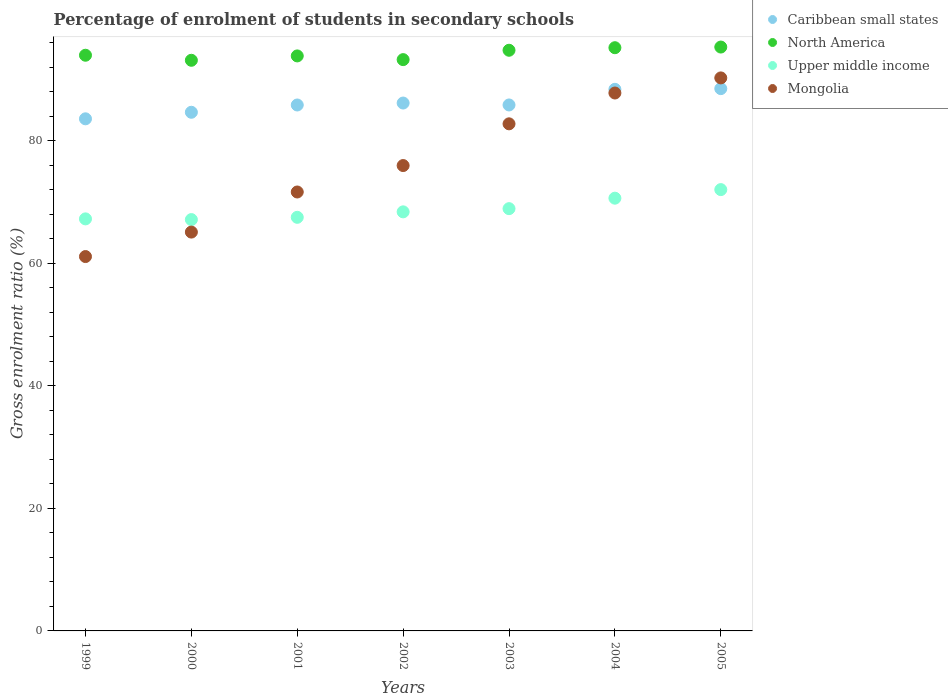What is the percentage of students enrolled in secondary schools in Mongolia in 2003?
Offer a terse response. 82.79. Across all years, what is the maximum percentage of students enrolled in secondary schools in Upper middle income?
Your response must be concise. 72.05. Across all years, what is the minimum percentage of students enrolled in secondary schools in Mongolia?
Offer a very short reply. 61.12. In which year was the percentage of students enrolled in secondary schools in Caribbean small states maximum?
Your answer should be very brief. 2005. In which year was the percentage of students enrolled in secondary schools in North America minimum?
Offer a very short reply. 2000. What is the total percentage of students enrolled in secondary schools in North America in the graph?
Provide a short and direct response. 659.68. What is the difference between the percentage of students enrolled in secondary schools in Caribbean small states in 2002 and that in 2004?
Your answer should be compact. -2.24. What is the difference between the percentage of students enrolled in secondary schools in Caribbean small states in 2003 and the percentage of students enrolled in secondary schools in Upper middle income in 1999?
Make the answer very short. 18.6. What is the average percentage of students enrolled in secondary schools in North America per year?
Make the answer very short. 94.24. In the year 2000, what is the difference between the percentage of students enrolled in secondary schools in North America and percentage of students enrolled in secondary schools in Caribbean small states?
Give a very brief answer. 8.49. What is the ratio of the percentage of students enrolled in secondary schools in North America in 2000 to that in 2005?
Make the answer very short. 0.98. Is the percentage of students enrolled in secondary schools in Upper middle income in 2000 less than that in 2004?
Provide a short and direct response. Yes. What is the difference between the highest and the second highest percentage of students enrolled in secondary schools in Upper middle income?
Your response must be concise. 1.4. What is the difference between the highest and the lowest percentage of students enrolled in secondary schools in North America?
Offer a terse response. 2.16. In how many years, is the percentage of students enrolled in secondary schools in North America greater than the average percentage of students enrolled in secondary schools in North America taken over all years?
Offer a very short reply. 3. Is the sum of the percentage of students enrolled in secondary schools in Caribbean small states in 1999 and 2003 greater than the maximum percentage of students enrolled in secondary schools in Upper middle income across all years?
Your response must be concise. Yes. Is it the case that in every year, the sum of the percentage of students enrolled in secondary schools in Upper middle income and percentage of students enrolled in secondary schools in Caribbean small states  is greater than the sum of percentage of students enrolled in secondary schools in North America and percentage of students enrolled in secondary schools in Mongolia?
Your response must be concise. No. Is the percentage of students enrolled in secondary schools in Mongolia strictly greater than the percentage of students enrolled in secondary schools in Upper middle income over the years?
Provide a short and direct response. No. Is the percentage of students enrolled in secondary schools in Caribbean small states strictly less than the percentage of students enrolled in secondary schools in Upper middle income over the years?
Ensure brevity in your answer.  No. Does the graph contain grids?
Your response must be concise. No. Where does the legend appear in the graph?
Ensure brevity in your answer.  Top right. How are the legend labels stacked?
Ensure brevity in your answer.  Vertical. What is the title of the graph?
Your answer should be very brief. Percentage of enrolment of students in secondary schools. Does "Armenia" appear as one of the legend labels in the graph?
Provide a short and direct response. No. What is the label or title of the Y-axis?
Offer a very short reply. Gross enrolment ratio (%). What is the Gross enrolment ratio (%) in Caribbean small states in 1999?
Your answer should be very brief. 83.61. What is the Gross enrolment ratio (%) in North America in 1999?
Offer a terse response. 93.99. What is the Gross enrolment ratio (%) of Upper middle income in 1999?
Provide a succinct answer. 67.27. What is the Gross enrolment ratio (%) in Mongolia in 1999?
Offer a terse response. 61.12. What is the Gross enrolment ratio (%) in Caribbean small states in 2000?
Offer a terse response. 84.68. What is the Gross enrolment ratio (%) in North America in 2000?
Your answer should be very brief. 93.17. What is the Gross enrolment ratio (%) in Upper middle income in 2000?
Keep it short and to the point. 67.16. What is the Gross enrolment ratio (%) of Mongolia in 2000?
Ensure brevity in your answer.  65.12. What is the Gross enrolment ratio (%) of Caribbean small states in 2001?
Offer a very short reply. 85.87. What is the Gross enrolment ratio (%) in North America in 2001?
Provide a succinct answer. 93.88. What is the Gross enrolment ratio (%) in Upper middle income in 2001?
Ensure brevity in your answer.  67.53. What is the Gross enrolment ratio (%) in Mongolia in 2001?
Keep it short and to the point. 71.67. What is the Gross enrolment ratio (%) in Caribbean small states in 2002?
Your answer should be very brief. 86.19. What is the Gross enrolment ratio (%) of North America in 2002?
Make the answer very short. 93.28. What is the Gross enrolment ratio (%) of Upper middle income in 2002?
Offer a terse response. 68.42. What is the Gross enrolment ratio (%) in Mongolia in 2002?
Provide a succinct answer. 75.98. What is the Gross enrolment ratio (%) in Caribbean small states in 2003?
Your answer should be compact. 85.87. What is the Gross enrolment ratio (%) of North America in 2003?
Give a very brief answer. 94.81. What is the Gross enrolment ratio (%) of Upper middle income in 2003?
Your answer should be compact. 68.94. What is the Gross enrolment ratio (%) in Mongolia in 2003?
Your response must be concise. 82.79. What is the Gross enrolment ratio (%) of Caribbean small states in 2004?
Offer a very short reply. 88.43. What is the Gross enrolment ratio (%) of North America in 2004?
Ensure brevity in your answer.  95.22. What is the Gross enrolment ratio (%) of Upper middle income in 2004?
Provide a succinct answer. 70.65. What is the Gross enrolment ratio (%) in Mongolia in 2004?
Your response must be concise. 87.83. What is the Gross enrolment ratio (%) in Caribbean small states in 2005?
Give a very brief answer. 88.54. What is the Gross enrolment ratio (%) of North America in 2005?
Make the answer very short. 95.33. What is the Gross enrolment ratio (%) in Upper middle income in 2005?
Your response must be concise. 72.05. What is the Gross enrolment ratio (%) in Mongolia in 2005?
Provide a succinct answer. 90.29. Across all years, what is the maximum Gross enrolment ratio (%) of Caribbean small states?
Ensure brevity in your answer.  88.54. Across all years, what is the maximum Gross enrolment ratio (%) in North America?
Make the answer very short. 95.33. Across all years, what is the maximum Gross enrolment ratio (%) of Upper middle income?
Provide a short and direct response. 72.05. Across all years, what is the maximum Gross enrolment ratio (%) in Mongolia?
Give a very brief answer. 90.29. Across all years, what is the minimum Gross enrolment ratio (%) in Caribbean small states?
Offer a terse response. 83.61. Across all years, what is the minimum Gross enrolment ratio (%) in North America?
Your answer should be very brief. 93.17. Across all years, what is the minimum Gross enrolment ratio (%) of Upper middle income?
Give a very brief answer. 67.16. Across all years, what is the minimum Gross enrolment ratio (%) of Mongolia?
Your response must be concise. 61.12. What is the total Gross enrolment ratio (%) in Caribbean small states in the graph?
Offer a terse response. 603.19. What is the total Gross enrolment ratio (%) in North America in the graph?
Your answer should be very brief. 659.68. What is the total Gross enrolment ratio (%) of Upper middle income in the graph?
Ensure brevity in your answer.  482.04. What is the total Gross enrolment ratio (%) in Mongolia in the graph?
Provide a short and direct response. 534.8. What is the difference between the Gross enrolment ratio (%) in Caribbean small states in 1999 and that in 2000?
Your response must be concise. -1.07. What is the difference between the Gross enrolment ratio (%) in North America in 1999 and that in 2000?
Your answer should be compact. 0.82. What is the difference between the Gross enrolment ratio (%) of Upper middle income in 1999 and that in 2000?
Your answer should be very brief. 0.12. What is the difference between the Gross enrolment ratio (%) in Mongolia in 1999 and that in 2000?
Keep it short and to the point. -3.99. What is the difference between the Gross enrolment ratio (%) in Caribbean small states in 1999 and that in 2001?
Your response must be concise. -2.26. What is the difference between the Gross enrolment ratio (%) of North America in 1999 and that in 2001?
Offer a terse response. 0.11. What is the difference between the Gross enrolment ratio (%) in Upper middle income in 1999 and that in 2001?
Your response must be concise. -0.26. What is the difference between the Gross enrolment ratio (%) in Mongolia in 1999 and that in 2001?
Offer a very short reply. -10.54. What is the difference between the Gross enrolment ratio (%) in Caribbean small states in 1999 and that in 2002?
Offer a very short reply. -2.58. What is the difference between the Gross enrolment ratio (%) in North America in 1999 and that in 2002?
Keep it short and to the point. 0.72. What is the difference between the Gross enrolment ratio (%) of Upper middle income in 1999 and that in 2002?
Make the answer very short. -1.15. What is the difference between the Gross enrolment ratio (%) of Mongolia in 1999 and that in 2002?
Keep it short and to the point. -14.86. What is the difference between the Gross enrolment ratio (%) in Caribbean small states in 1999 and that in 2003?
Provide a succinct answer. -2.26. What is the difference between the Gross enrolment ratio (%) in North America in 1999 and that in 2003?
Your response must be concise. -0.81. What is the difference between the Gross enrolment ratio (%) in Upper middle income in 1999 and that in 2003?
Provide a succinct answer. -1.67. What is the difference between the Gross enrolment ratio (%) of Mongolia in 1999 and that in 2003?
Your answer should be compact. -21.67. What is the difference between the Gross enrolment ratio (%) in Caribbean small states in 1999 and that in 2004?
Provide a succinct answer. -4.82. What is the difference between the Gross enrolment ratio (%) in North America in 1999 and that in 2004?
Keep it short and to the point. -1.23. What is the difference between the Gross enrolment ratio (%) of Upper middle income in 1999 and that in 2004?
Provide a short and direct response. -3.38. What is the difference between the Gross enrolment ratio (%) in Mongolia in 1999 and that in 2004?
Offer a terse response. -26.7. What is the difference between the Gross enrolment ratio (%) in Caribbean small states in 1999 and that in 2005?
Offer a very short reply. -4.93. What is the difference between the Gross enrolment ratio (%) of North America in 1999 and that in 2005?
Offer a terse response. -1.34. What is the difference between the Gross enrolment ratio (%) of Upper middle income in 1999 and that in 2005?
Keep it short and to the point. -4.78. What is the difference between the Gross enrolment ratio (%) of Mongolia in 1999 and that in 2005?
Your answer should be compact. -29.17. What is the difference between the Gross enrolment ratio (%) in Caribbean small states in 2000 and that in 2001?
Provide a succinct answer. -1.19. What is the difference between the Gross enrolment ratio (%) of North America in 2000 and that in 2001?
Provide a short and direct response. -0.71. What is the difference between the Gross enrolment ratio (%) in Upper middle income in 2000 and that in 2001?
Your response must be concise. -0.37. What is the difference between the Gross enrolment ratio (%) in Mongolia in 2000 and that in 2001?
Offer a very short reply. -6.55. What is the difference between the Gross enrolment ratio (%) of Caribbean small states in 2000 and that in 2002?
Offer a terse response. -1.51. What is the difference between the Gross enrolment ratio (%) of North America in 2000 and that in 2002?
Ensure brevity in your answer.  -0.11. What is the difference between the Gross enrolment ratio (%) of Upper middle income in 2000 and that in 2002?
Offer a terse response. -1.26. What is the difference between the Gross enrolment ratio (%) in Mongolia in 2000 and that in 2002?
Keep it short and to the point. -10.86. What is the difference between the Gross enrolment ratio (%) in Caribbean small states in 2000 and that in 2003?
Keep it short and to the point. -1.19. What is the difference between the Gross enrolment ratio (%) in North America in 2000 and that in 2003?
Your response must be concise. -1.64. What is the difference between the Gross enrolment ratio (%) of Upper middle income in 2000 and that in 2003?
Offer a terse response. -1.79. What is the difference between the Gross enrolment ratio (%) in Mongolia in 2000 and that in 2003?
Give a very brief answer. -17.68. What is the difference between the Gross enrolment ratio (%) of Caribbean small states in 2000 and that in 2004?
Offer a very short reply. -3.75. What is the difference between the Gross enrolment ratio (%) of North America in 2000 and that in 2004?
Provide a short and direct response. -2.05. What is the difference between the Gross enrolment ratio (%) of Upper middle income in 2000 and that in 2004?
Your answer should be very brief. -3.5. What is the difference between the Gross enrolment ratio (%) in Mongolia in 2000 and that in 2004?
Your answer should be very brief. -22.71. What is the difference between the Gross enrolment ratio (%) of Caribbean small states in 2000 and that in 2005?
Your answer should be very brief. -3.86. What is the difference between the Gross enrolment ratio (%) of North America in 2000 and that in 2005?
Your answer should be compact. -2.16. What is the difference between the Gross enrolment ratio (%) of Upper middle income in 2000 and that in 2005?
Provide a short and direct response. -4.9. What is the difference between the Gross enrolment ratio (%) of Mongolia in 2000 and that in 2005?
Ensure brevity in your answer.  -25.17. What is the difference between the Gross enrolment ratio (%) of Caribbean small states in 2001 and that in 2002?
Provide a short and direct response. -0.32. What is the difference between the Gross enrolment ratio (%) of North America in 2001 and that in 2002?
Make the answer very short. 0.6. What is the difference between the Gross enrolment ratio (%) of Upper middle income in 2001 and that in 2002?
Provide a succinct answer. -0.89. What is the difference between the Gross enrolment ratio (%) of Mongolia in 2001 and that in 2002?
Your answer should be very brief. -4.32. What is the difference between the Gross enrolment ratio (%) of Caribbean small states in 2001 and that in 2003?
Your response must be concise. -0.01. What is the difference between the Gross enrolment ratio (%) of North America in 2001 and that in 2003?
Offer a terse response. -0.93. What is the difference between the Gross enrolment ratio (%) in Upper middle income in 2001 and that in 2003?
Provide a succinct answer. -1.41. What is the difference between the Gross enrolment ratio (%) in Mongolia in 2001 and that in 2003?
Offer a terse response. -11.13. What is the difference between the Gross enrolment ratio (%) of Caribbean small states in 2001 and that in 2004?
Offer a terse response. -2.56. What is the difference between the Gross enrolment ratio (%) of North America in 2001 and that in 2004?
Offer a very short reply. -1.34. What is the difference between the Gross enrolment ratio (%) of Upper middle income in 2001 and that in 2004?
Provide a short and direct response. -3.12. What is the difference between the Gross enrolment ratio (%) of Mongolia in 2001 and that in 2004?
Ensure brevity in your answer.  -16.16. What is the difference between the Gross enrolment ratio (%) in Caribbean small states in 2001 and that in 2005?
Your answer should be very brief. -2.67. What is the difference between the Gross enrolment ratio (%) in North America in 2001 and that in 2005?
Keep it short and to the point. -1.45. What is the difference between the Gross enrolment ratio (%) in Upper middle income in 2001 and that in 2005?
Provide a succinct answer. -4.52. What is the difference between the Gross enrolment ratio (%) of Mongolia in 2001 and that in 2005?
Your answer should be very brief. -18.63. What is the difference between the Gross enrolment ratio (%) in Caribbean small states in 2002 and that in 2003?
Make the answer very short. 0.31. What is the difference between the Gross enrolment ratio (%) of North America in 2002 and that in 2003?
Offer a terse response. -1.53. What is the difference between the Gross enrolment ratio (%) of Upper middle income in 2002 and that in 2003?
Offer a terse response. -0.52. What is the difference between the Gross enrolment ratio (%) of Mongolia in 2002 and that in 2003?
Provide a succinct answer. -6.81. What is the difference between the Gross enrolment ratio (%) in Caribbean small states in 2002 and that in 2004?
Provide a short and direct response. -2.24. What is the difference between the Gross enrolment ratio (%) in North America in 2002 and that in 2004?
Your answer should be compact. -1.95. What is the difference between the Gross enrolment ratio (%) of Upper middle income in 2002 and that in 2004?
Provide a short and direct response. -2.23. What is the difference between the Gross enrolment ratio (%) of Mongolia in 2002 and that in 2004?
Keep it short and to the point. -11.84. What is the difference between the Gross enrolment ratio (%) of Caribbean small states in 2002 and that in 2005?
Give a very brief answer. -2.35. What is the difference between the Gross enrolment ratio (%) of North America in 2002 and that in 2005?
Make the answer very short. -2.05. What is the difference between the Gross enrolment ratio (%) in Upper middle income in 2002 and that in 2005?
Provide a short and direct response. -3.63. What is the difference between the Gross enrolment ratio (%) in Mongolia in 2002 and that in 2005?
Offer a terse response. -14.31. What is the difference between the Gross enrolment ratio (%) in Caribbean small states in 2003 and that in 2004?
Offer a terse response. -2.55. What is the difference between the Gross enrolment ratio (%) in North America in 2003 and that in 2004?
Your answer should be compact. -0.42. What is the difference between the Gross enrolment ratio (%) of Upper middle income in 2003 and that in 2004?
Your answer should be compact. -1.71. What is the difference between the Gross enrolment ratio (%) of Mongolia in 2003 and that in 2004?
Provide a succinct answer. -5.03. What is the difference between the Gross enrolment ratio (%) in Caribbean small states in 2003 and that in 2005?
Your response must be concise. -2.67. What is the difference between the Gross enrolment ratio (%) in North America in 2003 and that in 2005?
Provide a short and direct response. -0.52. What is the difference between the Gross enrolment ratio (%) of Upper middle income in 2003 and that in 2005?
Provide a succinct answer. -3.11. What is the difference between the Gross enrolment ratio (%) in Mongolia in 2003 and that in 2005?
Your answer should be compact. -7.5. What is the difference between the Gross enrolment ratio (%) in Caribbean small states in 2004 and that in 2005?
Give a very brief answer. -0.11. What is the difference between the Gross enrolment ratio (%) in North America in 2004 and that in 2005?
Your answer should be very brief. -0.11. What is the difference between the Gross enrolment ratio (%) of Upper middle income in 2004 and that in 2005?
Your answer should be compact. -1.4. What is the difference between the Gross enrolment ratio (%) in Mongolia in 2004 and that in 2005?
Your answer should be very brief. -2.47. What is the difference between the Gross enrolment ratio (%) in Caribbean small states in 1999 and the Gross enrolment ratio (%) in North America in 2000?
Keep it short and to the point. -9.56. What is the difference between the Gross enrolment ratio (%) in Caribbean small states in 1999 and the Gross enrolment ratio (%) in Upper middle income in 2000?
Your response must be concise. 16.45. What is the difference between the Gross enrolment ratio (%) of Caribbean small states in 1999 and the Gross enrolment ratio (%) of Mongolia in 2000?
Your answer should be very brief. 18.49. What is the difference between the Gross enrolment ratio (%) of North America in 1999 and the Gross enrolment ratio (%) of Upper middle income in 2000?
Make the answer very short. 26.83. What is the difference between the Gross enrolment ratio (%) in North America in 1999 and the Gross enrolment ratio (%) in Mongolia in 2000?
Make the answer very short. 28.88. What is the difference between the Gross enrolment ratio (%) in Upper middle income in 1999 and the Gross enrolment ratio (%) in Mongolia in 2000?
Provide a succinct answer. 2.16. What is the difference between the Gross enrolment ratio (%) in Caribbean small states in 1999 and the Gross enrolment ratio (%) in North America in 2001?
Give a very brief answer. -10.27. What is the difference between the Gross enrolment ratio (%) in Caribbean small states in 1999 and the Gross enrolment ratio (%) in Upper middle income in 2001?
Ensure brevity in your answer.  16.08. What is the difference between the Gross enrolment ratio (%) of Caribbean small states in 1999 and the Gross enrolment ratio (%) of Mongolia in 2001?
Provide a succinct answer. 11.95. What is the difference between the Gross enrolment ratio (%) in North America in 1999 and the Gross enrolment ratio (%) in Upper middle income in 2001?
Offer a terse response. 26.46. What is the difference between the Gross enrolment ratio (%) in North America in 1999 and the Gross enrolment ratio (%) in Mongolia in 2001?
Your answer should be very brief. 22.33. What is the difference between the Gross enrolment ratio (%) in Upper middle income in 1999 and the Gross enrolment ratio (%) in Mongolia in 2001?
Offer a very short reply. -4.39. What is the difference between the Gross enrolment ratio (%) in Caribbean small states in 1999 and the Gross enrolment ratio (%) in North America in 2002?
Make the answer very short. -9.66. What is the difference between the Gross enrolment ratio (%) of Caribbean small states in 1999 and the Gross enrolment ratio (%) of Upper middle income in 2002?
Provide a short and direct response. 15.19. What is the difference between the Gross enrolment ratio (%) of Caribbean small states in 1999 and the Gross enrolment ratio (%) of Mongolia in 2002?
Offer a terse response. 7.63. What is the difference between the Gross enrolment ratio (%) in North America in 1999 and the Gross enrolment ratio (%) in Upper middle income in 2002?
Your answer should be very brief. 25.57. What is the difference between the Gross enrolment ratio (%) of North America in 1999 and the Gross enrolment ratio (%) of Mongolia in 2002?
Offer a terse response. 18.01. What is the difference between the Gross enrolment ratio (%) in Upper middle income in 1999 and the Gross enrolment ratio (%) in Mongolia in 2002?
Your answer should be very brief. -8.71. What is the difference between the Gross enrolment ratio (%) of Caribbean small states in 1999 and the Gross enrolment ratio (%) of North America in 2003?
Provide a short and direct response. -11.19. What is the difference between the Gross enrolment ratio (%) of Caribbean small states in 1999 and the Gross enrolment ratio (%) of Upper middle income in 2003?
Offer a very short reply. 14.67. What is the difference between the Gross enrolment ratio (%) of Caribbean small states in 1999 and the Gross enrolment ratio (%) of Mongolia in 2003?
Offer a terse response. 0.82. What is the difference between the Gross enrolment ratio (%) in North America in 1999 and the Gross enrolment ratio (%) in Upper middle income in 2003?
Your answer should be compact. 25.05. What is the difference between the Gross enrolment ratio (%) in North America in 1999 and the Gross enrolment ratio (%) in Mongolia in 2003?
Make the answer very short. 11.2. What is the difference between the Gross enrolment ratio (%) in Upper middle income in 1999 and the Gross enrolment ratio (%) in Mongolia in 2003?
Your answer should be very brief. -15.52. What is the difference between the Gross enrolment ratio (%) of Caribbean small states in 1999 and the Gross enrolment ratio (%) of North America in 2004?
Provide a short and direct response. -11.61. What is the difference between the Gross enrolment ratio (%) of Caribbean small states in 1999 and the Gross enrolment ratio (%) of Upper middle income in 2004?
Your answer should be very brief. 12.96. What is the difference between the Gross enrolment ratio (%) of Caribbean small states in 1999 and the Gross enrolment ratio (%) of Mongolia in 2004?
Ensure brevity in your answer.  -4.21. What is the difference between the Gross enrolment ratio (%) in North America in 1999 and the Gross enrolment ratio (%) in Upper middle income in 2004?
Offer a very short reply. 23.34. What is the difference between the Gross enrolment ratio (%) of North America in 1999 and the Gross enrolment ratio (%) of Mongolia in 2004?
Offer a very short reply. 6.17. What is the difference between the Gross enrolment ratio (%) in Upper middle income in 1999 and the Gross enrolment ratio (%) in Mongolia in 2004?
Give a very brief answer. -20.55. What is the difference between the Gross enrolment ratio (%) in Caribbean small states in 1999 and the Gross enrolment ratio (%) in North America in 2005?
Offer a terse response. -11.72. What is the difference between the Gross enrolment ratio (%) in Caribbean small states in 1999 and the Gross enrolment ratio (%) in Upper middle income in 2005?
Offer a very short reply. 11.56. What is the difference between the Gross enrolment ratio (%) in Caribbean small states in 1999 and the Gross enrolment ratio (%) in Mongolia in 2005?
Your response must be concise. -6.68. What is the difference between the Gross enrolment ratio (%) of North America in 1999 and the Gross enrolment ratio (%) of Upper middle income in 2005?
Your response must be concise. 21.94. What is the difference between the Gross enrolment ratio (%) in North America in 1999 and the Gross enrolment ratio (%) in Mongolia in 2005?
Your answer should be compact. 3.7. What is the difference between the Gross enrolment ratio (%) in Upper middle income in 1999 and the Gross enrolment ratio (%) in Mongolia in 2005?
Keep it short and to the point. -23.02. What is the difference between the Gross enrolment ratio (%) of Caribbean small states in 2000 and the Gross enrolment ratio (%) of North America in 2001?
Your answer should be very brief. -9.2. What is the difference between the Gross enrolment ratio (%) of Caribbean small states in 2000 and the Gross enrolment ratio (%) of Upper middle income in 2001?
Make the answer very short. 17.15. What is the difference between the Gross enrolment ratio (%) of Caribbean small states in 2000 and the Gross enrolment ratio (%) of Mongolia in 2001?
Offer a terse response. 13.02. What is the difference between the Gross enrolment ratio (%) of North America in 2000 and the Gross enrolment ratio (%) of Upper middle income in 2001?
Offer a terse response. 25.64. What is the difference between the Gross enrolment ratio (%) in North America in 2000 and the Gross enrolment ratio (%) in Mongolia in 2001?
Keep it short and to the point. 21.5. What is the difference between the Gross enrolment ratio (%) of Upper middle income in 2000 and the Gross enrolment ratio (%) of Mongolia in 2001?
Offer a terse response. -4.51. What is the difference between the Gross enrolment ratio (%) of Caribbean small states in 2000 and the Gross enrolment ratio (%) of North America in 2002?
Offer a terse response. -8.59. What is the difference between the Gross enrolment ratio (%) in Caribbean small states in 2000 and the Gross enrolment ratio (%) in Upper middle income in 2002?
Provide a succinct answer. 16.26. What is the difference between the Gross enrolment ratio (%) of Caribbean small states in 2000 and the Gross enrolment ratio (%) of Mongolia in 2002?
Make the answer very short. 8.7. What is the difference between the Gross enrolment ratio (%) in North America in 2000 and the Gross enrolment ratio (%) in Upper middle income in 2002?
Keep it short and to the point. 24.75. What is the difference between the Gross enrolment ratio (%) in North America in 2000 and the Gross enrolment ratio (%) in Mongolia in 2002?
Offer a terse response. 17.19. What is the difference between the Gross enrolment ratio (%) in Upper middle income in 2000 and the Gross enrolment ratio (%) in Mongolia in 2002?
Offer a terse response. -8.82. What is the difference between the Gross enrolment ratio (%) in Caribbean small states in 2000 and the Gross enrolment ratio (%) in North America in 2003?
Make the answer very short. -10.12. What is the difference between the Gross enrolment ratio (%) in Caribbean small states in 2000 and the Gross enrolment ratio (%) in Upper middle income in 2003?
Keep it short and to the point. 15.74. What is the difference between the Gross enrolment ratio (%) in Caribbean small states in 2000 and the Gross enrolment ratio (%) in Mongolia in 2003?
Provide a short and direct response. 1.89. What is the difference between the Gross enrolment ratio (%) of North America in 2000 and the Gross enrolment ratio (%) of Upper middle income in 2003?
Offer a very short reply. 24.22. What is the difference between the Gross enrolment ratio (%) of North America in 2000 and the Gross enrolment ratio (%) of Mongolia in 2003?
Ensure brevity in your answer.  10.38. What is the difference between the Gross enrolment ratio (%) in Upper middle income in 2000 and the Gross enrolment ratio (%) in Mongolia in 2003?
Give a very brief answer. -15.63. What is the difference between the Gross enrolment ratio (%) of Caribbean small states in 2000 and the Gross enrolment ratio (%) of North America in 2004?
Your answer should be very brief. -10.54. What is the difference between the Gross enrolment ratio (%) of Caribbean small states in 2000 and the Gross enrolment ratio (%) of Upper middle income in 2004?
Make the answer very short. 14.03. What is the difference between the Gross enrolment ratio (%) in Caribbean small states in 2000 and the Gross enrolment ratio (%) in Mongolia in 2004?
Provide a short and direct response. -3.14. What is the difference between the Gross enrolment ratio (%) in North America in 2000 and the Gross enrolment ratio (%) in Upper middle income in 2004?
Provide a short and direct response. 22.51. What is the difference between the Gross enrolment ratio (%) of North America in 2000 and the Gross enrolment ratio (%) of Mongolia in 2004?
Your answer should be compact. 5.34. What is the difference between the Gross enrolment ratio (%) of Upper middle income in 2000 and the Gross enrolment ratio (%) of Mongolia in 2004?
Make the answer very short. -20.67. What is the difference between the Gross enrolment ratio (%) of Caribbean small states in 2000 and the Gross enrolment ratio (%) of North America in 2005?
Your response must be concise. -10.65. What is the difference between the Gross enrolment ratio (%) of Caribbean small states in 2000 and the Gross enrolment ratio (%) of Upper middle income in 2005?
Your answer should be very brief. 12.63. What is the difference between the Gross enrolment ratio (%) of Caribbean small states in 2000 and the Gross enrolment ratio (%) of Mongolia in 2005?
Provide a short and direct response. -5.61. What is the difference between the Gross enrolment ratio (%) of North America in 2000 and the Gross enrolment ratio (%) of Upper middle income in 2005?
Make the answer very short. 21.11. What is the difference between the Gross enrolment ratio (%) of North America in 2000 and the Gross enrolment ratio (%) of Mongolia in 2005?
Your response must be concise. 2.88. What is the difference between the Gross enrolment ratio (%) in Upper middle income in 2000 and the Gross enrolment ratio (%) in Mongolia in 2005?
Make the answer very short. -23.13. What is the difference between the Gross enrolment ratio (%) of Caribbean small states in 2001 and the Gross enrolment ratio (%) of North America in 2002?
Offer a terse response. -7.41. What is the difference between the Gross enrolment ratio (%) in Caribbean small states in 2001 and the Gross enrolment ratio (%) in Upper middle income in 2002?
Keep it short and to the point. 17.45. What is the difference between the Gross enrolment ratio (%) of Caribbean small states in 2001 and the Gross enrolment ratio (%) of Mongolia in 2002?
Offer a very short reply. 9.89. What is the difference between the Gross enrolment ratio (%) in North America in 2001 and the Gross enrolment ratio (%) in Upper middle income in 2002?
Your answer should be very brief. 25.46. What is the difference between the Gross enrolment ratio (%) in North America in 2001 and the Gross enrolment ratio (%) in Mongolia in 2002?
Ensure brevity in your answer.  17.9. What is the difference between the Gross enrolment ratio (%) in Upper middle income in 2001 and the Gross enrolment ratio (%) in Mongolia in 2002?
Offer a terse response. -8.45. What is the difference between the Gross enrolment ratio (%) of Caribbean small states in 2001 and the Gross enrolment ratio (%) of North America in 2003?
Provide a succinct answer. -8.94. What is the difference between the Gross enrolment ratio (%) in Caribbean small states in 2001 and the Gross enrolment ratio (%) in Upper middle income in 2003?
Provide a succinct answer. 16.93. What is the difference between the Gross enrolment ratio (%) in Caribbean small states in 2001 and the Gross enrolment ratio (%) in Mongolia in 2003?
Offer a very short reply. 3.08. What is the difference between the Gross enrolment ratio (%) of North America in 2001 and the Gross enrolment ratio (%) of Upper middle income in 2003?
Keep it short and to the point. 24.94. What is the difference between the Gross enrolment ratio (%) of North America in 2001 and the Gross enrolment ratio (%) of Mongolia in 2003?
Your answer should be very brief. 11.09. What is the difference between the Gross enrolment ratio (%) in Upper middle income in 2001 and the Gross enrolment ratio (%) in Mongolia in 2003?
Your answer should be compact. -15.26. What is the difference between the Gross enrolment ratio (%) of Caribbean small states in 2001 and the Gross enrolment ratio (%) of North America in 2004?
Make the answer very short. -9.35. What is the difference between the Gross enrolment ratio (%) in Caribbean small states in 2001 and the Gross enrolment ratio (%) in Upper middle income in 2004?
Your answer should be very brief. 15.22. What is the difference between the Gross enrolment ratio (%) of Caribbean small states in 2001 and the Gross enrolment ratio (%) of Mongolia in 2004?
Give a very brief answer. -1.96. What is the difference between the Gross enrolment ratio (%) in North America in 2001 and the Gross enrolment ratio (%) in Upper middle income in 2004?
Give a very brief answer. 23.23. What is the difference between the Gross enrolment ratio (%) in North America in 2001 and the Gross enrolment ratio (%) in Mongolia in 2004?
Provide a short and direct response. 6.05. What is the difference between the Gross enrolment ratio (%) in Upper middle income in 2001 and the Gross enrolment ratio (%) in Mongolia in 2004?
Provide a short and direct response. -20.3. What is the difference between the Gross enrolment ratio (%) in Caribbean small states in 2001 and the Gross enrolment ratio (%) in North America in 2005?
Provide a succinct answer. -9.46. What is the difference between the Gross enrolment ratio (%) of Caribbean small states in 2001 and the Gross enrolment ratio (%) of Upper middle income in 2005?
Give a very brief answer. 13.82. What is the difference between the Gross enrolment ratio (%) of Caribbean small states in 2001 and the Gross enrolment ratio (%) of Mongolia in 2005?
Keep it short and to the point. -4.42. What is the difference between the Gross enrolment ratio (%) in North America in 2001 and the Gross enrolment ratio (%) in Upper middle income in 2005?
Your answer should be very brief. 21.83. What is the difference between the Gross enrolment ratio (%) of North America in 2001 and the Gross enrolment ratio (%) of Mongolia in 2005?
Make the answer very short. 3.59. What is the difference between the Gross enrolment ratio (%) of Upper middle income in 2001 and the Gross enrolment ratio (%) of Mongolia in 2005?
Your answer should be compact. -22.76. What is the difference between the Gross enrolment ratio (%) of Caribbean small states in 2002 and the Gross enrolment ratio (%) of North America in 2003?
Give a very brief answer. -8.62. What is the difference between the Gross enrolment ratio (%) of Caribbean small states in 2002 and the Gross enrolment ratio (%) of Upper middle income in 2003?
Provide a succinct answer. 17.24. What is the difference between the Gross enrolment ratio (%) of Caribbean small states in 2002 and the Gross enrolment ratio (%) of Mongolia in 2003?
Offer a very short reply. 3.4. What is the difference between the Gross enrolment ratio (%) in North America in 2002 and the Gross enrolment ratio (%) in Upper middle income in 2003?
Make the answer very short. 24.33. What is the difference between the Gross enrolment ratio (%) in North America in 2002 and the Gross enrolment ratio (%) in Mongolia in 2003?
Make the answer very short. 10.48. What is the difference between the Gross enrolment ratio (%) in Upper middle income in 2002 and the Gross enrolment ratio (%) in Mongolia in 2003?
Offer a very short reply. -14.37. What is the difference between the Gross enrolment ratio (%) in Caribbean small states in 2002 and the Gross enrolment ratio (%) in North America in 2004?
Ensure brevity in your answer.  -9.03. What is the difference between the Gross enrolment ratio (%) of Caribbean small states in 2002 and the Gross enrolment ratio (%) of Upper middle income in 2004?
Your answer should be compact. 15.53. What is the difference between the Gross enrolment ratio (%) in Caribbean small states in 2002 and the Gross enrolment ratio (%) in Mongolia in 2004?
Provide a short and direct response. -1.64. What is the difference between the Gross enrolment ratio (%) of North America in 2002 and the Gross enrolment ratio (%) of Upper middle income in 2004?
Offer a very short reply. 22.62. What is the difference between the Gross enrolment ratio (%) of North America in 2002 and the Gross enrolment ratio (%) of Mongolia in 2004?
Offer a terse response. 5.45. What is the difference between the Gross enrolment ratio (%) in Upper middle income in 2002 and the Gross enrolment ratio (%) in Mongolia in 2004?
Offer a very short reply. -19.4. What is the difference between the Gross enrolment ratio (%) of Caribbean small states in 2002 and the Gross enrolment ratio (%) of North America in 2005?
Offer a terse response. -9.14. What is the difference between the Gross enrolment ratio (%) of Caribbean small states in 2002 and the Gross enrolment ratio (%) of Upper middle income in 2005?
Your answer should be compact. 14.13. What is the difference between the Gross enrolment ratio (%) of Caribbean small states in 2002 and the Gross enrolment ratio (%) of Mongolia in 2005?
Offer a very short reply. -4.1. What is the difference between the Gross enrolment ratio (%) of North America in 2002 and the Gross enrolment ratio (%) of Upper middle income in 2005?
Your answer should be compact. 21.22. What is the difference between the Gross enrolment ratio (%) in North America in 2002 and the Gross enrolment ratio (%) in Mongolia in 2005?
Give a very brief answer. 2.98. What is the difference between the Gross enrolment ratio (%) of Upper middle income in 2002 and the Gross enrolment ratio (%) of Mongolia in 2005?
Offer a very short reply. -21.87. What is the difference between the Gross enrolment ratio (%) in Caribbean small states in 2003 and the Gross enrolment ratio (%) in North America in 2004?
Your response must be concise. -9.35. What is the difference between the Gross enrolment ratio (%) of Caribbean small states in 2003 and the Gross enrolment ratio (%) of Upper middle income in 2004?
Provide a succinct answer. 15.22. What is the difference between the Gross enrolment ratio (%) of Caribbean small states in 2003 and the Gross enrolment ratio (%) of Mongolia in 2004?
Offer a terse response. -1.95. What is the difference between the Gross enrolment ratio (%) in North America in 2003 and the Gross enrolment ratio (%) in Upper middle income in 2004?
Make the answer very short. 24.15. What is the difference between the Gross enrolment ratio (%) in North America in 2003 and the Gross enrolment ratio (%) in Mongolia in 2004?
Your answer should be very brief. 6.98. What is the difference between the Gross enrolment ratio (%) of Upper middle income in 2003 and the Gross enrolment ratio (%) of Mongolia in 2004?
Give a very brief answer. -18.88. What is the difference between the Gross enrolment ratio (%) in Caribbean small states in 2003 and the Gross enrolment ratio (%) in North America in 2005?
Ensure brevity in your answer.  -9.45. What is the difference between the Gross enrolment ratio (%) in Caribbean small states in 2003 and the Gross enrolment ratio (%) in Upper middle income in 2005?
Your answer should be compact. 13.82. What is the difference between the Gross enrolment ratio (%) of Caribbean small states in 2003 and the Gross enrolment ratio (%) of Mongolia in 2005?
Your answer should be very brief. -4.42. What is the difference between the Gross enrolment ratio (%) in North America in 2003 and the Gross enrolment ratio (%) in Upper middle income in 2005?
Provide a short and direct response. 22.75. What is the difference between the Gross enrolment ratio (%) in North America in 2003 and the Gross enrolment ratio (%) in Mongolia in 2005?
Offer a very short reply. 4.51. What is the difference between the Gross enrolment ratio (%) in Upper middle income in 2003 and the Gross enrolment ratio (%) in Mongolia in 2005?
Keep it short and to the point. -21.35. What is the difference between the Gross enrolment ratio (%) of Caribbean small states in 2004 and the Gross enrolment ratio (%) of North America in 2005?
Give a very brief answer. -6.9. What is the difference between the Gross enrolment ratio (%) in Caribbean small states in 2004 and the Gross enrolment ratio (%) in Upper middle income in 2005?
Offer a very short reply. 16.37. What is the difference between the Gross enrolment ratio (%) in Caribbean small states in 2004 and the Gross enrolment ratio (%) in Mongolia in 2005?
Give a very brief answer. -1.86. What is the difference between the Gross enrolment ratio (%) of North America in 2004 and the Gross enrolment ratio (%) of Upper middle income in 2005?
Provide a short and direct response. 23.17. What is the difference between the Gross enrolment ratio (%) in North America in 2004 and the Gross enrolment ratio (%) in Mongolia in 2005?
Provide a short and direct response. 4.93. What is the difference between the Gross enrolment ratio (%) of Upper middle income in 2004 and the Gross enrolment ratio (%) of Mongolia in 2005?
Offer a terse response. -19.64. What is the average Gross enrolment ratio (%) of Caribbean small states per year?
Keep it short and to the point. 86.17. What is the average Gross enrolment ratio (%) of North America per year?
Provide a short and direct response. 94.24. What is the average Gross enrolment ratio (%) of Upper middle income per year?
Provide a short and direct response. 68.86. What is the average Gross enrolment ratio (%) of Mongolia per year?
Provide a short and direct response. 76.4. In the year 1999, what is the difference between the Gross enrolment ratio (%) of Caribbean small states and Gross enrolment ratio (%) of North America?
Ensure brevity in your answer.  -10.38. In the year 1999, what is the difference between the Gross enrolment ratio (%) of Caribbean small states and Gross enrolment ratio (%) of Upper middle income?
Your response must be concise. 16.34. In the year 1999, what is the difference between the Gross enrolment ratio (%) in Caribbean small states and Gross enrolment ratio (%) in Mongolia?
Ensure brevity in your answer.  22.49. In the year 1999, what is the difference between the Gross enrolment ratio (%) of North America and Gross enrolment ratio (%) of Upper middle income?
Give a very brief answer. 26.72. In the year 1999, what is the difference between the Gross enrolment ratio (%) in North America and Gross enrolment ratio (%) in Mongolia?
Your response must be concise. 32.87. In the year 1999, what is the difference between the Gross enrolment ratio (%) in Upper middle income and Gross enrolment ratio (%) in Mongolia?
Make the answer very short. 6.15. In the year 2000, what is the difference between the Gross enrolment ratio (%) in Caribbean small states and Gross enrolment ratio (%) in North America?
Provide a succinct answer. -8.49. In the year 2000, what is the difference between the Gross enrolment ratio (%) of Caribbean small states and Gross enrolment ratio (%) of Upper middle income?
Make the answer very short. 17.52. In the year 2000, what is the difference between the Gross enrolment ratio (%) of Caribbean small states and Gross enrolment ratio (%) of Mongolia?
Make the answer very short. 19.56. In the year 2000, what is the difference between the Gross enrolment ratio (%) of North America and Gross enrolment ratio (%) of Upper middle income?
Your answer should be compact. 26.01. In the year 2000, what is the difference between the Gross enrolment ratio (%) in North America and Gross enrolment ratio (%) in Mongolia?
Make the answer very short. 28.05. In the year 2000, what is the difference between the Gross enrolment ratio (%) in Upper middle income and Gross enrolment ratio (%) in Mongolia?
Make the answer very short. 2.04. In the year 2001, what is the difference between the Gross enrolment ratio (%) in Caribbean small states and Gross enrolment ratio (%) in North America?
Your response must be concise. -8.01. In the year 2001, what is the difference between the Gross enrolment ratio (%) in Caribbean small states and Gross enrolment ratio (%) in Upper middle income?
Provide a succinct answer. 18.34. In the year 2001, what is the difference between the Gross enrolment ratio (%) in Caribbean small states and Gross enrolment ratio (%) in Mongolia?
Offer a terse response. 14.2. In the year 2001, what is the difference between the Gross enrolment ratio (%) of North America and Gross enrolment ratio (%) of Upper middle income?
Offer a terse response. 26.35. In the year 2001, what is the difference between the Gross enrolment ratio (%) in North America and Gross enrolment ratio (%) in Mongolia?
Keep it short and to the point. 22.22. In the year 2001, what is the difference between the Gross enrolment ratio (%) of Upper middle income and Gross enrolment ratio (%) of Mongolia?
Offer a terse response. -4.14. In the year 2002, what is the difference between the Gross enrolment ratio (%) of Caribbean small states and Gross enrolment ratio (%) of North America?
Offer a very short reply. -7.09. In the year 2002, what is the difference between the Gross enrolment ratio (%) of Caribbean small states and Gross enrolment ratio (%) of Upper middle income?
Provide a short and direct response. 17.77. In the year 2002, what is the difference between the Gross enrolment ratio (%) of Caribbean small states and Gross enrolment ratio (%) of Mongolia?
Your answer should be compact. 10.21. In the year 2002, what is the difference between the Gross enrolment ratio (%) in North America and Gross enrolment ratio (%) in Upper middle income?
Your response must be concise. 24.85. In the year 2002, what is the difference between the Gross enrolment ratio (%) in North America and Gross enrolment ratio (%) in Mongolia?
Give a very brief answer. 17.3. In the year 2002, what is the difference between the Gross enrolment ratio (%) of Upper middle income and Gross enrolment ratio (%) of Mongolia?
Make the answer very short. -7.56. In the year 2003, what is the difference between the Gross enrolment ratio (%) of Caribbean small states and Gross enrolment ratio (%) of North America?
Ensure brevity in your answer.  -8.93. In the year 2003, what is the difference between the Gross enrolment ratio (%) of Caribbean small states and Gross enrolment ratio (%) of Upper middle income?
Ensure brevity in your answer.  16.93. In the year 2003, what is the difference between the Gross enrolment ratio (%) of Caribbean small states and Gross enrolment ratio (%) of Mongolia?
Provide a succinct answer. 3.08. In the year 2003, what is the difference between the Gross enrolment ratio (%) in North America and Gross enrolment ratio (%) in Upper middle income?
Provide a short and direct response. 25.86. In the year 2003, what is the difference between the Gross enrolment ratio (%) in North America and Gross enrolment ratio (%) in Mongolia?
Your answer should be very brief. 12.01. In the year 2003, what is the difference between the Gross enrolment ratio (%) of Upper middle income and Gross enrolment ratio (%) of Mongolia?
Offer a very short reply. -13.85. In the year 2004, what is the difference between the Gross enrolment ratio (%) of Caribbean small states and Gross enrolment ratio (%) of North America?
Ensure brevity in your answer.  -6.79. In the year 2004, what is the difference between the Gross enrolment ratio (%) in Caribbean small states and Gross enrolment ratio (%) in Upper middle income?
Ensure brevity in your answer.  17.77. In the year 2004, what is the difference between the Gross enrolment ratio (%) in Caribbean small states and Gross enrolment ratio (%) in Mongolia?
Your response must be concise. 0.6. In the year 2004, what is the difference between the Gross enrolment ratio (%) of North America and Gross enrolment ratio (%) of Upper middle income?
Provide a succinct answer. 24.57. In the year 2004, what is the difference between the Gross enrolment ratio (%) of North America and Gross enrolment ratio (%) of Mongolia?
Your answer should be compact. 7.4. In the year 2004, what is the difference between the Gross enrolment ratio (%) in Upper middle income and Gross enrolment ratio (%) in Mongolia?
Offer a terse response. -17.17. In the year 2005, what is the difference between the Gross enrolment ratio (%) of Caribbean small states and Gross enrolment ratio (%) of North America?
Offer a very short reply. -6.79. In the year 2005, what is the difference between the Gross enrolment ratio (%) in Caribbean small states and Gross enrolment ratio (%) in Upper middle income?
Offer a very short reply. 16.49. In the year 2005, what is the difference between the Gross enrolment ratio (%) in Caribbean small states and Gross enrolment ratio (%) in Mongolia?
Provide a succinct answer. -1.75. In the year 2005, what is the difference between the Gross enrolment ratio (%) in North America and Gross enrolment ratio (%) in Upper middle income?
Provide a succinct answer. 23.28. In the year 2005, what is the difference between the Gross enrolment ratio (%) in North America and Gross enrolment ratio (%) in Mongolia?
Your answer should be very brief. 5.04. In the year 2005, what is the difference between the Gross enrolment ratio (%) of Upper middle income and Gross enrolment ratio (%) of Mongolia?
Keep it short and to the point. -18.24. What is the ratio of the Gross enrolment ratio (%) of Caribbean small states in 1999 to that in 2000?
Ensure brevity in your answer.  0.99. What is the ratio of the Gross enrolment ratio (%) of North America in 1999 to that in 2000?
Provide a succinct answer. 1.01. What is the ratio of the Gross enrolment ratio (%) of Upper middle income in 1999 to that in 2000?
Offer a very short reply. 1. What is the ratio of the Gross enrolment ratio (%) of Mongolia in 1999 to that in 2000?
Ensure brevity in your answer.  0.94. What is the ratio of the Gross enrolment ratio (%) of Caribbean small states in 1999 to that in 2001?
Your response must be concise. 0.97. What is the ratio of the Gross enrolment ratio (%) in North America in 1999 to that in 2001?
Your answer should be very brief. 1. What is the ratio of the Gross enrolment ratio (%) in Mongolia in 1999 to that in 2001?
Your response must be concise. 0.85. What is the ratio of the Gross enrolment ratio (%) of Caribbean small states in 1999 to that in 2002?
Provide a succinct answer. 0.97. What is the ratio of the Gross enrolment ratio (%) in North America in 1999 to that in 2002?
Your answer should be very brief. 1.01. What is the ratio of the Gross enrolment ratio (%) of Upper middle income in 1999 to that in 2002?
Offer a terse response. 0.98. What is the ratio of the Gross enrolment ratio (%) of Mongolia in 1999 to that in 2002?
Provide a short and direct response. 0.8. What is the ratio of the Gross enrolment ratio (%) in Caribbean small states in 1999 to that in 2003?
Your answer should be compact. 0.97. What is the ratio of the Gross enrolment ratio (%) in Upper middle income in 1999 to that in 2003?
Provide a short and direct response. 0.98. What is the ratio of the Gross enrolment ratio (%) of Mongolia in 1999 to that in 2003?
Give a very brief answer. 0.74. What is the ratio of the Gross enrolment ratio (%) in Caribbean small states in 1999 to that in 2004?
Ensure brevity in your answer.  0.95. What is the ratio of the Gross enrolment ratio (%) of North America in 1999 to that in 2004?
Ensure brevity in your answer.  0.99. What is the ratio of the Gross enrolment ratio (%) of Upper middle income in 1999 to that in 2004?
Offer a terse response. 0.95. What is the ratio of the Gross enrolment ratio (%) of Mongolia in 1999 to that in 2004?
Offer a very short reply. 0.7. What is the ratio of the Gross enrolment ratio (%) in Caribbean small states in 1999 to that in 2005?
Keep it short and to the point. 0.94. What is the ratio of the Gross enrolment ratio (%) in North America in 1999 to that in 2005?
Provide a short and direct response. 0.99. What is the ratio of the Gross enrolment ratio (%) of Upper middle income in 1999 to that in 2005?
Your response must be concise. 0.93. What is the ratio of the Gross enrolment ratio (%) of Mongolia in 1999 to that in 2005?
Provide a short and direct response. 0.68. What is the ratio of the Gross enrolment ratio (%) of Caribbean small states in 2000 to that in 2001?
Your answer should be compact. 0.99. What is the ratio of the Gross enrolment ratio (%) of North America in 2000 to that in 2001?
Your answer should be very brief. 0.99. What is the ratio of the Gross enrolment ratio (%) in Mongolia in 2000 to that in 2001?
Give a very brief answer. 0.91. What is the ratio of the Gross enrolment ratio (%) of Caribbean small states in 2000 to that in 2002?
Offer a terse response. 0.98. What is the ratio of the Gross enrolment ratio (%) in North America in 2000 to that in 2002?
Provide a short and direct response. 1. What is the ratio of the Gross enrolment ratio (%) in Upper middle income in 2000 to that in 2002?
Ensure brevity in your answer.  0.98. What is the ratio of the Gross enrolment ratio (%) of Mongolia in 2000 to that in 2002?
Keep it short and to the point. 0.86. What is the ratio of the Gross enrolment ratio (%) in Caribbean small states in 2000 to that in 2003?
Provide a succinct answer. 0.99. What is the ratio of the Gross enrolment ratio (%) in North America in 2000 to that in 2003?
Provide a short and direct response. 0.98. What is the ratio of the Gross enrolment ratio (%) of Upper middle income in 2000 to that in 2003?
Keep it short and to the point. 0.97. What is the ratio of the Gross enrolment ratio (%) of Mongolia in 2000 to that in 2003?
Provide a short and direct response. 0.79. What is the ratio of the Gross enrolment ratio (%) in Caribbean small states in 2000 to that in 2004?
Your response must be concise. 0.96. What is the ratio of the Gross enrolment ratio (%) of North America in 2000 to that in 2004?
Ensure brevity in your answer.  0.98. What is the ratio of the Gross enrolment ratio (%) in Upper middle income in 2000 to that in 2004?
Your response must be concise. 0.95. What is the ratio of the Gross enrolment ratio (%) in Mongolia in 2000 to that in 2004?
Your answer should be very brief. 0.74. What is the ratio of the Gross enrolment ratio (%) of Caribbean small states in 2000 to that in 2005?
Ensure brevity in your answer.  0.96. What is the ratio of the Gross enrolment ratio (%) of North America in 2000 to that in 2005?
Give a very brief answer. 0.98. What is the ratio of the Gross enrolment ratio (%) of Upper middle income in 2000 to that in 2005?
Provide a succinct answer. 0.93. What is the ratio of the Gross enrolment ratio (%) in Mongolia in 2000 to that in 2005?
Offer a very short reply. 0.72. What is the ratio of the Gross enrolment ratio (%) of Upper middle income in 2001 to that in 2002?
Provide a succinct answer. 0.99. What is the ratio of the Gross enrolment ratio (%) of Mongolia in 2001 to that in 2002?
Make the answer very short. 0.94. What is the ratio of the Gross enrolment ratio (%) in North America in 2001 to that in 2003?
Provide a succinct answer. 0.99. What is the ratio of the Gross enrolment ratio (%) in Upper middle income in 2001 to that in 2003?
Give a very brief answer. 0.98. What is the ratio of the Gross enrolment ratio (%) of Mongolia in 2001 to that in 2003?
Your answer should be very brief. 0.87. What is the ratio of the Gross enrolment ratio (%) in Caribbean small states in 2001 to that in 2004?
Keep it short and to the point. 0.97. What is the ratio of the Gross enrolment ratio (%) of North America in 2001 to that in 2004?
Make the answer very short. 0.99. What is the ratio of the Gross enrolment ratio (%) of Upper middle income in 2001 to that in 2004?
Provide a succinct answer. 0.96. What is the ratio of the Gross enrolment ratio (%) of Mongolia in 2001 to that in 2004?
Offer a very short reply. 0.82. What is the ratio of the Gross enrolment ratio (%) in Caribbean small states in 2001 to that in 2005?
Offer a terse response. 0.97. What is the ratio of the Gross enrolment ratio (%) of Upper middle income in 2001 to that in 2005?
Give a very brief answer. 0.94. What is the ratio of the Gross enrolment ratio (%) of Mongolia in 2001 to that in 2005?
Make the answer very short. 0.79. What is the ratio of the Gross enrolment ratio (%) of Caribbean small states in 2002 to that in 2003?
Your answer should be compact. 1. What is the ratio of the Gross enrolment ratio (%) in North America in 2002 to that in 2003?
Give a very brief answer. 0.98. What is the ratio of the Gross enrolment ratio (%) in Mongolia in 2002 to that in 2003?
Ensure brevity in your answer.  0.92. What is the ratio of the Gross enrolment ratio (%) in Caribbean small states in 2002 to that in 2004?
Ensure brevity in your answer.  0.97. What is the ratio of the Gross enrolment ratio (%) in North America in 2002 to that in 2004?
Your answer should be very brief. 0.98. What is the ratio of the Gross enrolment ratio (%) of Upper middle income in 2002 to that in 2004?
Your answer should be very brief. 0.97. What is the ratio of the Gross enrolment ratio (%) in Mongolia in 2002 to that in 2004?
Ensure brevity in your answer.  0.87. What is the ratio of the Gross enrolment ratio (%) in Caribbean small states in 2002 to that in 2005?
Make the answer very short. 0.97. What is the ratio of the Gross enrolment ratio (%) in North America in 2002 to that in 2005?
Your response must be concise. 0.98. What is the ratio of the Gross enrolment ratio (%) in Upper middle income in 2002 to that in 2005?
Offer a very short reply. 0.95. What is the ratio of the Gross enrolment ratio (%) in Mongolia in 2002 to that in 2005?
Make the answer very short. 0.84. What is the ratio of the Gross enrolment ratio (%) in Caribbean small states in 2003 to that in 2004?
Provide a succinct answer. 0.97. What is the ratio of the Gross enrolment ratio (%) in Upper middle income in 2003 to that in 2004?
Ensure brevity in your answer.  0.98. What is the ratio of the Gross enrolment ratio (%) in Mongolia in 2003 to that in 2004?
Provide a short and direct response. 0.94. What is the ratio of the Gross enrolment ratio (%) in Caribbean small states in 2003 to that in 2005?
Make the answer very short. 0.97. What is the ratio of the Gross enrolment ratio (%) in Upper middle income in 2003 to that in 2005?
Provide a short and direct response. 0.96. What is the ratio of the Gross enrolment ratio (%) of Mongolia in 2003 to that in 2005?
Keep it short and to the point. 0.92. What is the ratio of the Gross enrolment ratio (%) in North America in 2004 to that in 2005?
Provide a succinct answer. 1. What is the ratio of the Gross enrolment ratio (%) of Upper middle income in 2004 to that in 2005?
Offer a terse response. 0.98. What is the ratio of the Gross enrolment ratio (%) in Mongolia in 2004 to that in 2005?
Keep it short and to the point. 0.97. What is the difference between the highest and the second highest Gross enrolment ratio (%) of Caribbean small states?
Keep it short and to the point. 0.11. What is the difference between the highest and the second highest Gross enrolment ratio (%) in North America?
Offer a terse response. 0.11. What is the difference between the highest and the second highest Gross enrolment ratio (%) of Upper middle income?
Provide a succinct answer. 1.4. What is the difference between the highest and the second highest Gross enrolment ratio (%) in Mongolia?
Your answer should be compact. 2.47. What is the difference between the highest and the lowest Gross enrolment ratio (%) in Caribbean small states?
Your answer should be very brief. 4.93. What is the difference between the highest and the lowest Gross enrolment ratio (%) in North America?
Keep it short and to the point. 2.16. What is the difference between the highest and the lowest Gross enrolment ratio (%) of Upper middle income?
Keep it short and to the point. 4.9. What is the difference between the highest and the lowest Gross enrolment ratio (%) of Mongolia?
Keep it short and to the point. 29.17. 